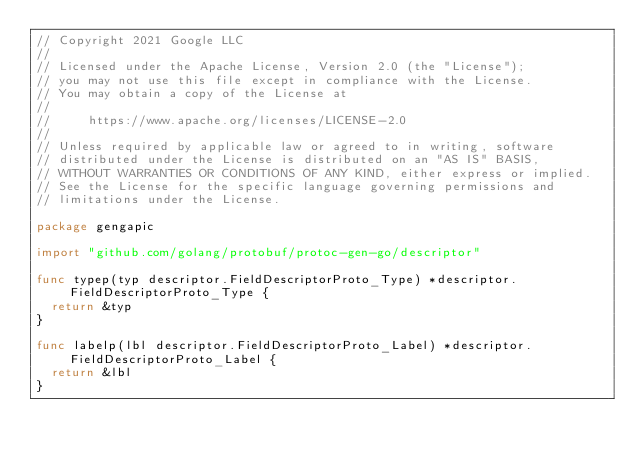Convert code to text. <code><loc_0><loc_0><loc_500><loc_500><_Go_>// Copyright 2021 Google LLC
//
// Licensed under the Apache License, Version 2.0 (the "License");
// you may not use this file except in compliance with the License.
// You may obtain a copy of the License at
//
//     https://www.apache.org/licenses/LICENSE-2.0
//
// Unless required by applicable law or agreed to in writing, software
// distributed under the License is distributed on an "AS IS" BASIS,
// WITHOUT WARRANTIES OR CONDITIONS OF ANY KIND, either express or implied.
// See the License for the specific language governing permissions and
// limitations under the License.

package gengapic

import "github.com/golang/protobuf/protoc-gen-go/descriptor"

func typep(typ descriptor.FieldDescriptorProto_Type) *descriptor.FieldDescriptorProto_Type {
	return &typ
}

func labelp(lbl descriptor.FieldDescriptorProto_Label) *descriptor.FieldDescriptorProto_Label {
	return &lbl
}
</code> 